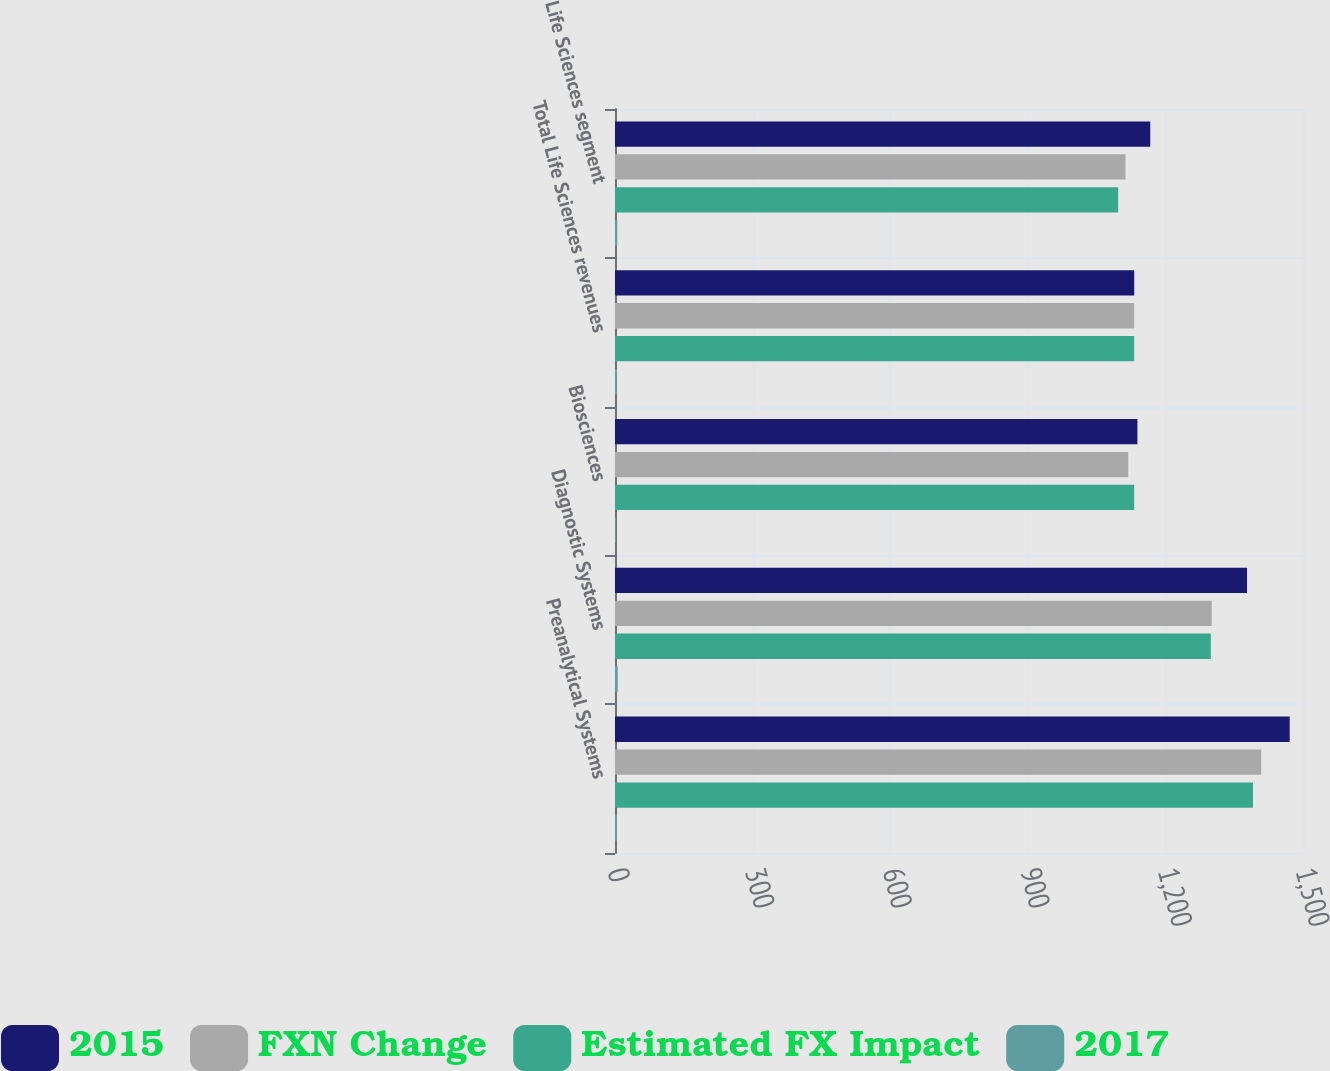Convert chart. <chart><loc_0><loc_0><loc_500><loc_500><stacked_bar_chart><ecel><fcel>Preanalytical Systems<fcel>Diagnostic Systems<fcel>Biosciences<fcel>Total Life Sciences revenues<fcel>Life Sciences segment<nl><fcel>2015<fcel>1471<fcel>1378<fcel>1139<fcel>1132<fcel>1167<nl><fcel>FXN Change<fcel>1409<fcel>1301<fcel>1119<fcel>1132<fcel>1113<nl><fcel>Estimated FX Impact<fcel>1391<fcel>1299<fcel>1132<fcel>1132<fcel>1097<nl><fcel>2017<fcel>4.4<fcel>5.9<fcel>1.8<fcel>4.2<fcel>4.9<nl></chart> 